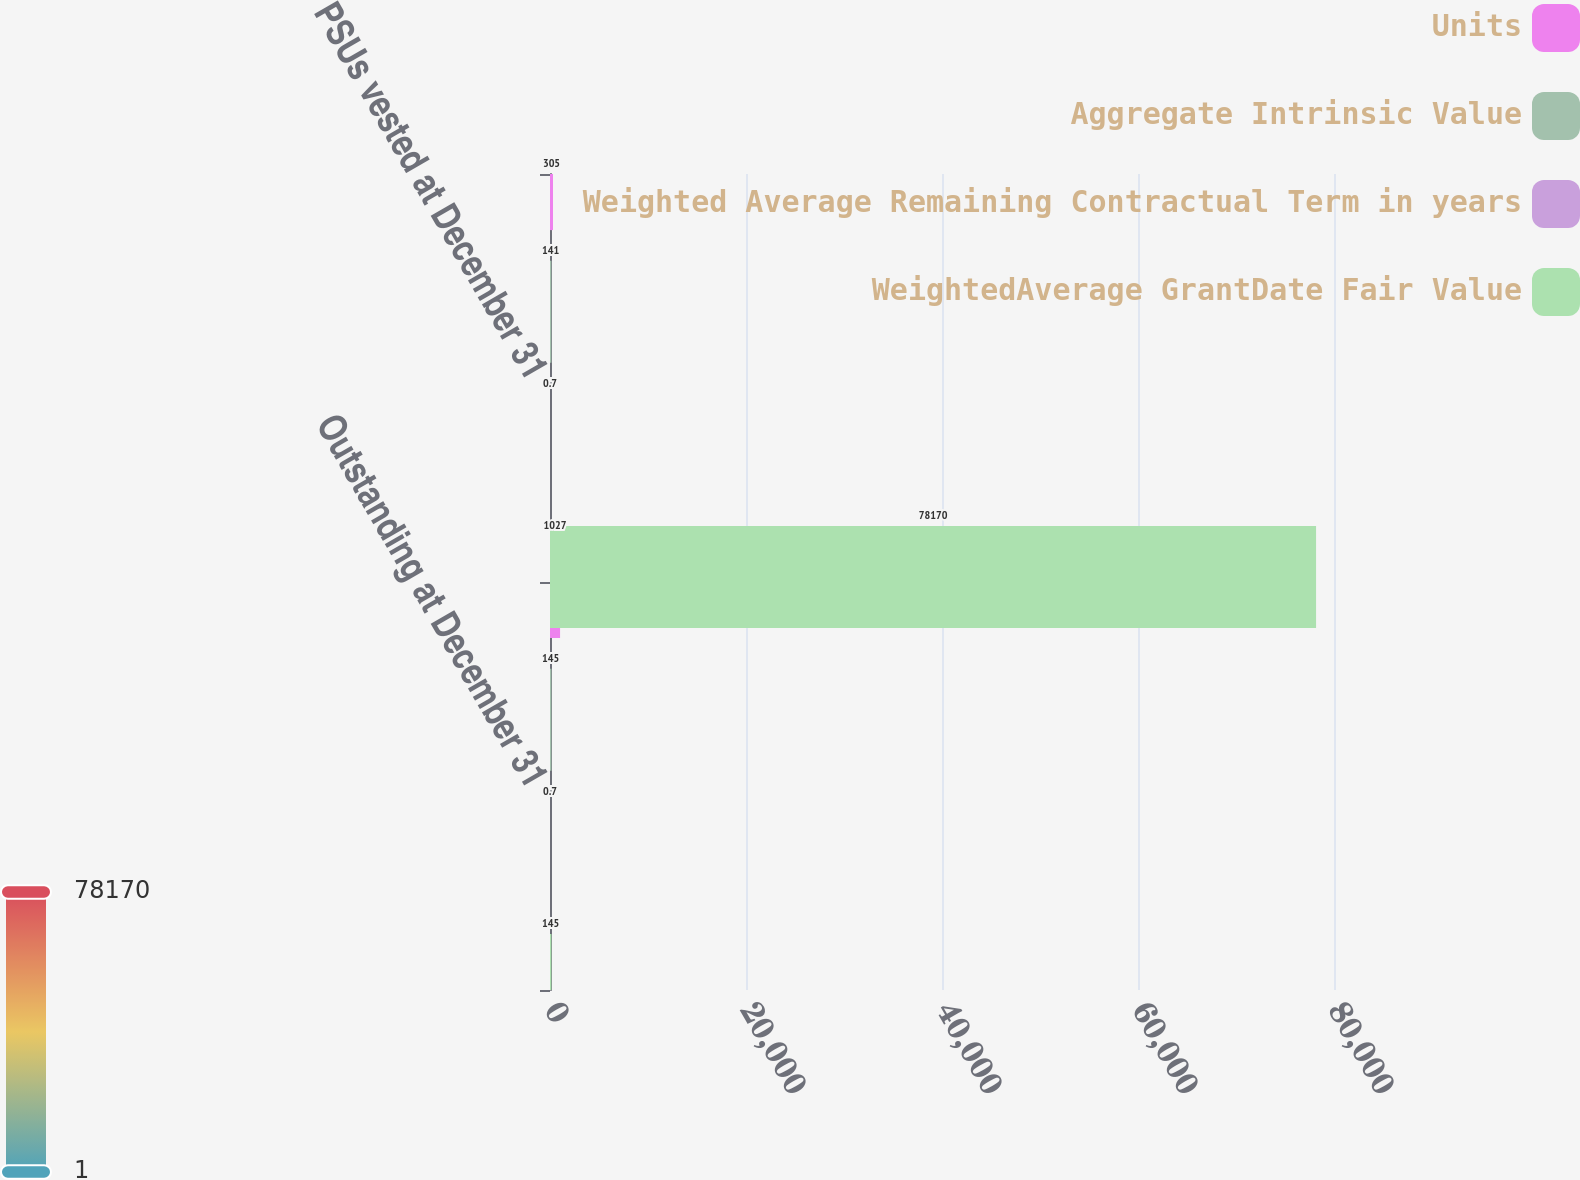Convert chart to OTSL. <chart><loc_0><loc_0><loc_500><loc_500><stacked_bar_chart><ecel><fcel>Outstanding at December 31<fcel>PSUs vested at December 31<nl><fcel>Units<fcel>1027<fcel>305<nl><fcel>Aggregate Intrinsic Value<fcel>145<fcel>141<nl><fcel>Weighted Average Remaining Contractual Term in years<fcel>0.7<fcel>0.7<nl><fcel>WeightedAverage GrantDate Fair Value<fcel>145<fcel>78170<nl></chart> 